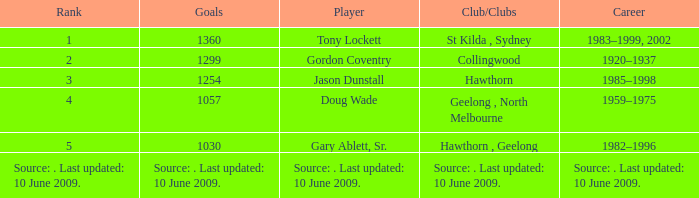Who is the player with 1299 goals to their name? Gordon Coventry. 